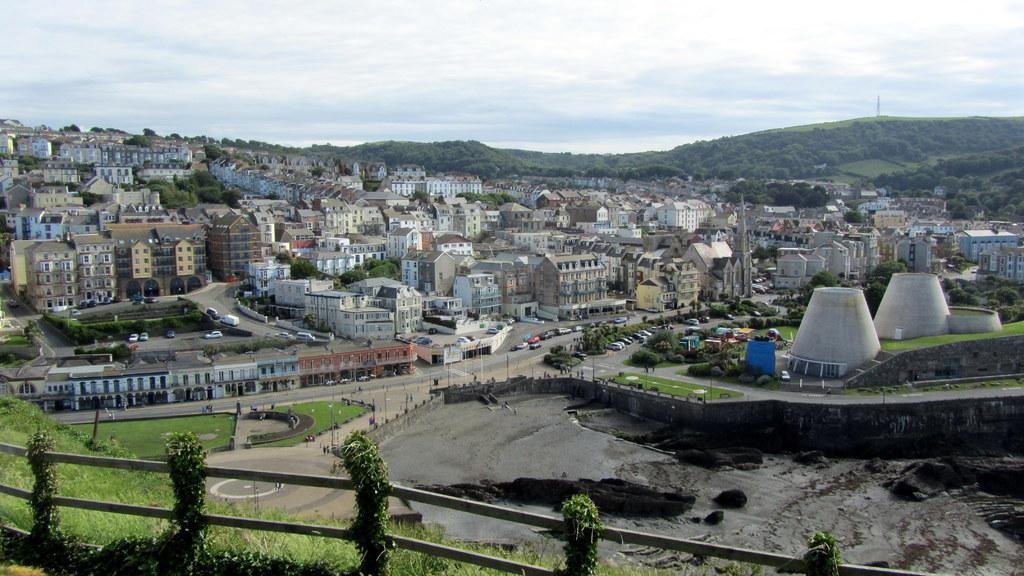What structures are located in the middle of the picture? There are buildings in the middle of the picture. What can be seen at the bottom of the picture? There is a railing at the bottom of the picture. What type of natural environment is visible in the background of the picture? There are trees in the background of the picture. What is visible in the sky in the background of the picture? The sky is visible in the background of the picture. What type of punishment is being carried out in the office in the image? There is no office or punishment present in the image. What type of business is being conducted in the background of the picture? There is no business activity depicted in the image; it features buildings, a railing, trees, and the sky. 